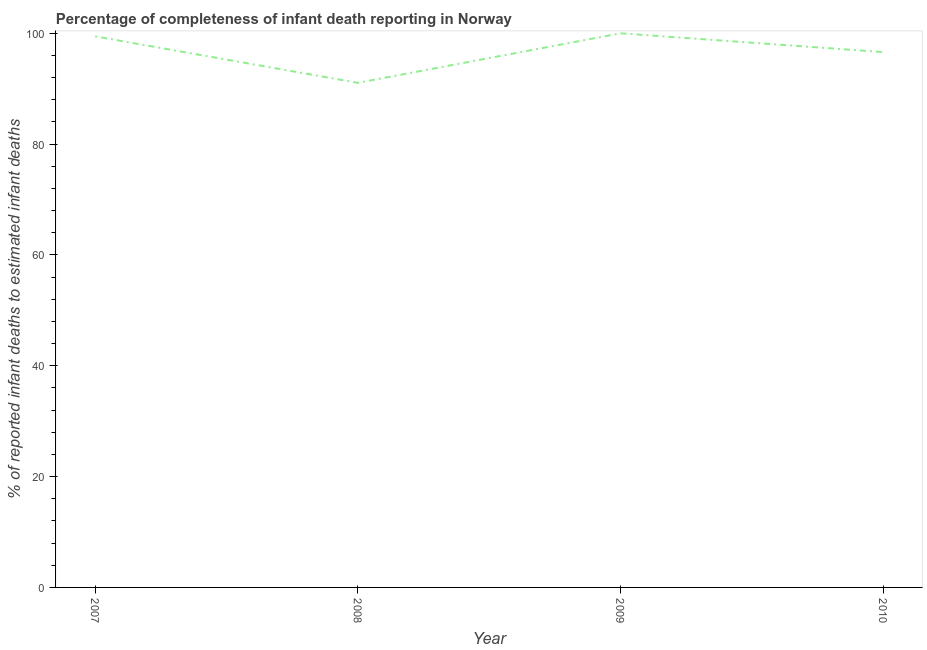What is the completeness of infant death reporting in 2007?
Your response must be concise. 99.45. Across all years, what is the maximum completeness of infant death reporting?
Make the answer very short. 100. Across all years, what is the minimum completeness of infant death reporting?
Offer a terse response. 91.06. What is the sum of the completeness of infant death reporting?
Provide a succinct answer. 387.12. What is the difference between the completeness of infant death reporting in 2007 and 2009?
Provide a short and direct response. -0.55. What is the average completeness of infant death reporting per year?
Make the answer very short. 96.78. What is the median completeness of infant death reporting?
Give a very brief answer. 98.03. In how many years, is the completeness of infant death reporting greater than 96 %?
Provide a succinct answer. 3. Do a majority of the years between 2009 and 2007 (inclusive) have completeness of infant death reporting greater than 12 %?
Provide a succinct answer. No. What is the ratio of the completeness of infant death reporting in 2008 to that in 2010?
Give a very brief answer. 0.94. Is the completeness of infant death reporting in 2007 less than that in 2009?
Your response must be concise. Yes. What is the difference between the highest and the second highest completeness of infant death reporting?
Your answer should be very brief. 0.55. What is the difference between the highest and the lowest completeness of infant death reporting?
Your response must be concise. 8.94. How many lines are there?
Make the answer very short. 1. How many years are there in the graph?
Your answer should be very brief. 4. Are the values on the major ticks of Y-axis written in scientific E-notation?
Provide a succinct answer. No. What is the title of the graph?
Offer a terse response. Percentage of completeness of infant death reporting in Norway. What is the label or title of the X-axis?
Provide a succinct answer. Year. What is the label or title of the Y-axis?
Offer a very short reply. % of reported infant deaths to estimated infant deaths. What is the % of reported infant deaths to estimated infant deaths in 2007?
Ensure brevity in your answer.  99.45. What is the % of reported infant deaths to estimated infant deaths of 2008?
Provide a succinct answer. 91.06. What is the % of reported infant deaths to estimated infant deaths of 2010?
Your answer should be very brief. 96.61. What is the difference between the % of reported infant deaths to estimated infant deaths in 2007 and 2008?
Provide a short and direct response. 8.39. What is the difference between the % of reported infant deaths to estimated infant deaths in 2007 and 2009?
Offer a terse response. -0.55. What is the difference between the % of reported infant deaths to estimated infant deaths in 2007 and 2010?
Give a very brief answer. 2.84. What is the difference between the % of reported infant deaths to estimated infant deaths in 2008 and 2009?
Your answer should be very brief. -8.94. What is the difference between the % of reported infant deaths to estimated infant deaths in 2008 and 2010?
Your response must be concise. -5.55. What is the difference between the % of reported infant deaths to estimated infant deaths in 2009 and 2010?
Your answer should be compact. 3.39. What is the ratio of the % of reported infant deaths to estimated infant deaths in 2007 to that in 2008?
Keep it short and to the point. 1.09. What is the ratio of the % of reported infant deaths to estimated infant deaths in 2007 to that in 2009?
Give a very brief answer. 0.99. What is the ratio of the % of reported infant deaths to estimated infant deaths in 2008 to that in 2009?
Give a very brief answer. 0.91. What is the ratio of the % of reported infant deaths to estimated infant deaths in 2008 to that in 2010?
Keep it short and to the point. 0.94. What is the ratio of the % of reported infant deaths to estimated infant deaths in 2009 to that in 2010?
Your answer should be very brief. 1.03. 